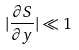<formula> <loc_0><loc_0><loc_500><loc_500>| \frac { \partial S } { \partial y } | \ll 1</formula> 